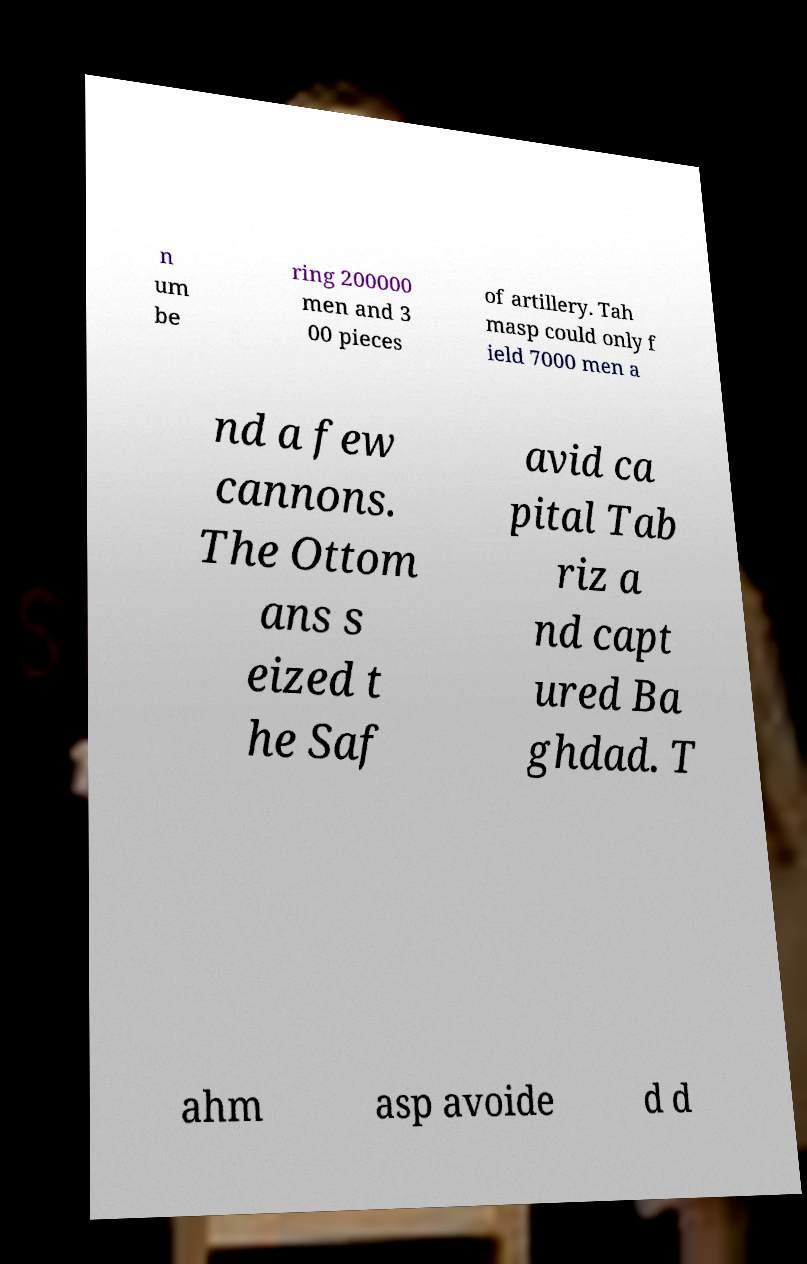Please identify and transcribe the text found in this image. n um be ring 200000 men and 3 00 pieces of artillery. Tah masp could only f ield 7000 men a nd a few cannons. The Ottom ans s eized t he Saf avid ca pital Tab riz a nd capt ured Ba ghdad. T ahm asp avoide d d 